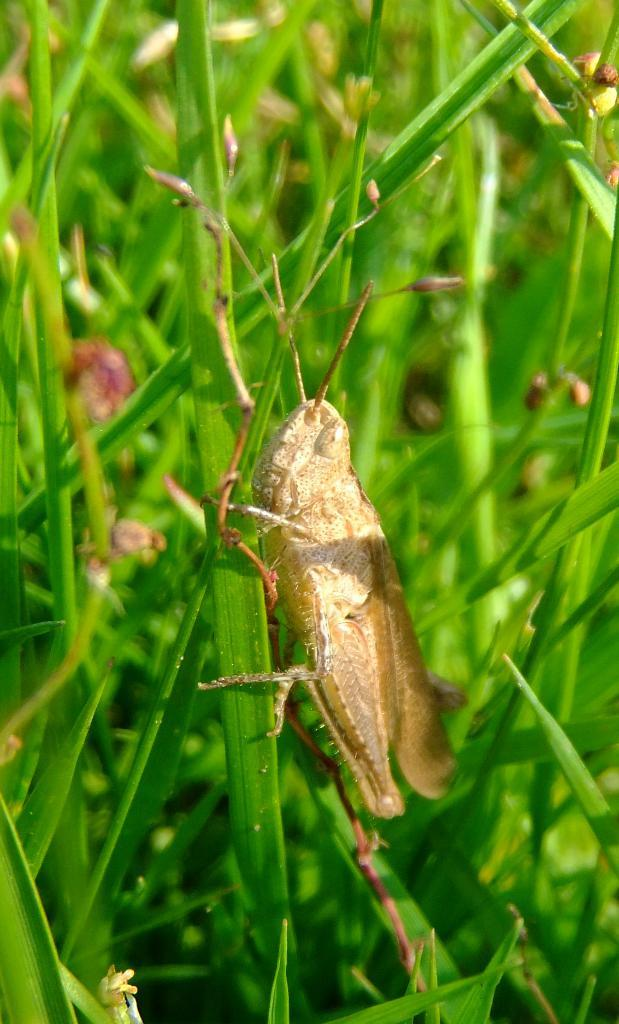What type of insect is in the image? There is a grasshopper in the image. What is the grasshopper standing on? The grasshopper is standing on the grass. What type of vegetable is growing next to the grasshopper in the image? There is no vegetable present in the image; it only features a grasshopper standing on the grass. 